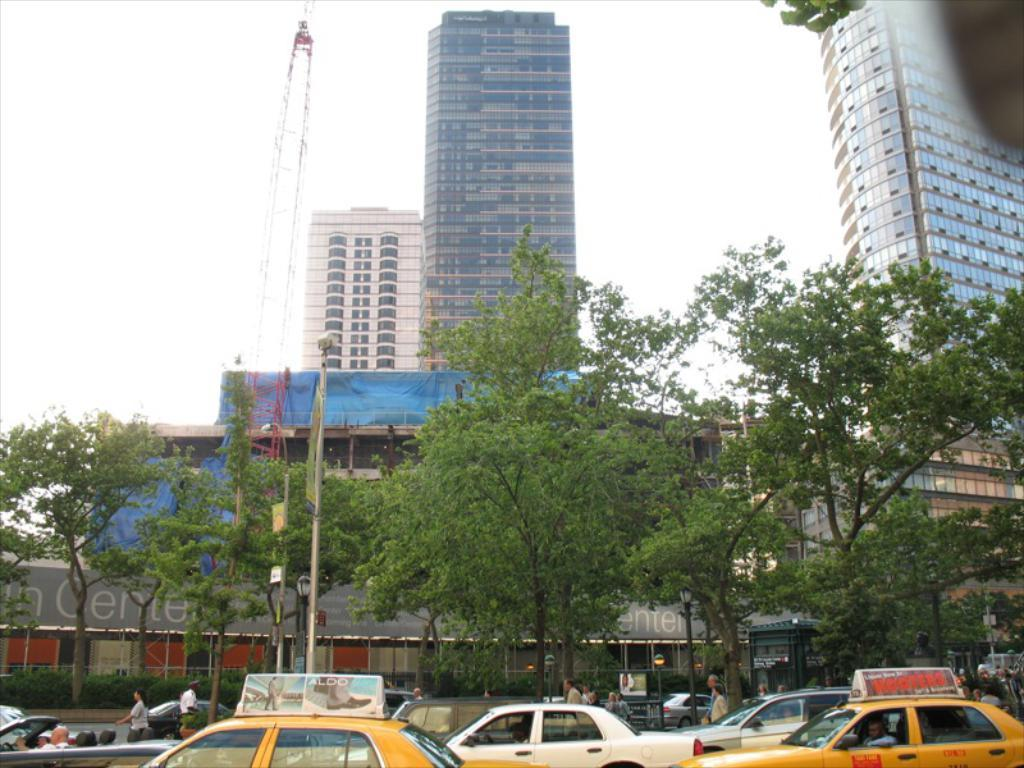<image>
Render a clear and concise summary of the photo. Two yellow taxi cabs with ads for Hooters and Aldo on their roofs sit in the traffic of a busy city street. 